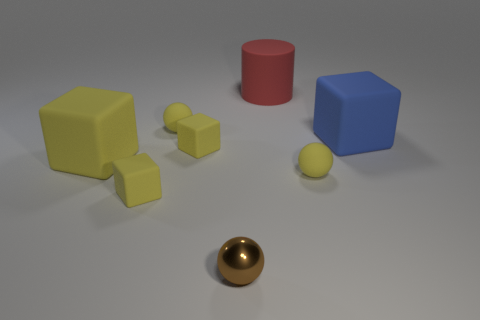Subtract all yellow rubber cubes. How many cubes are left? 1 Subtract all blue cylinders. How many yellow spheres are left? 2 Subtract all blue blocks. How many blocks are left? 3 Subtract 1 cubes. How many cubes are left? 3 Add 1 large spheres. How many objects exist? 9 Subtract all gray blocks. Subtract all gray balls. How many blocks are left? 4 Subtract all balls. How many objects are left? 5 Subtract all big red rubber cylinders. Subtract all small yellow cubes. How many objects are left? 5 Add 7 matte spheres. How many matte spheres are left? 9 Add 4 tiny brown metal things. How many tiny brown metal things exist? 5 